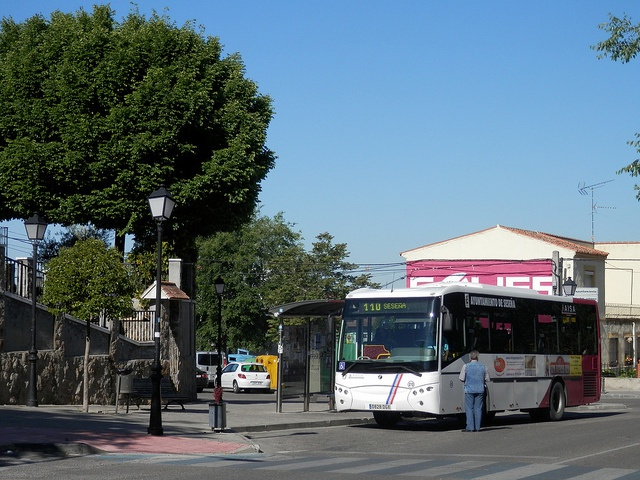Describe the objects in this image and their specific colors. I can see bus in gray, black, white, and navy tones, people in gray, blue, and black tones, car in gray, lightgray, black, and darkgray tones, bench in gray, black, and darkgray tones, and car in gray, black, and darkgray tones in this image. 